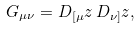Convert formula to latex. <formula><loc_0><loc_0><loc_500><loc_500>G _ { \mu \nu } = D _ { [ \mu } z \, D _ { \nu ] } z ,</formula> 